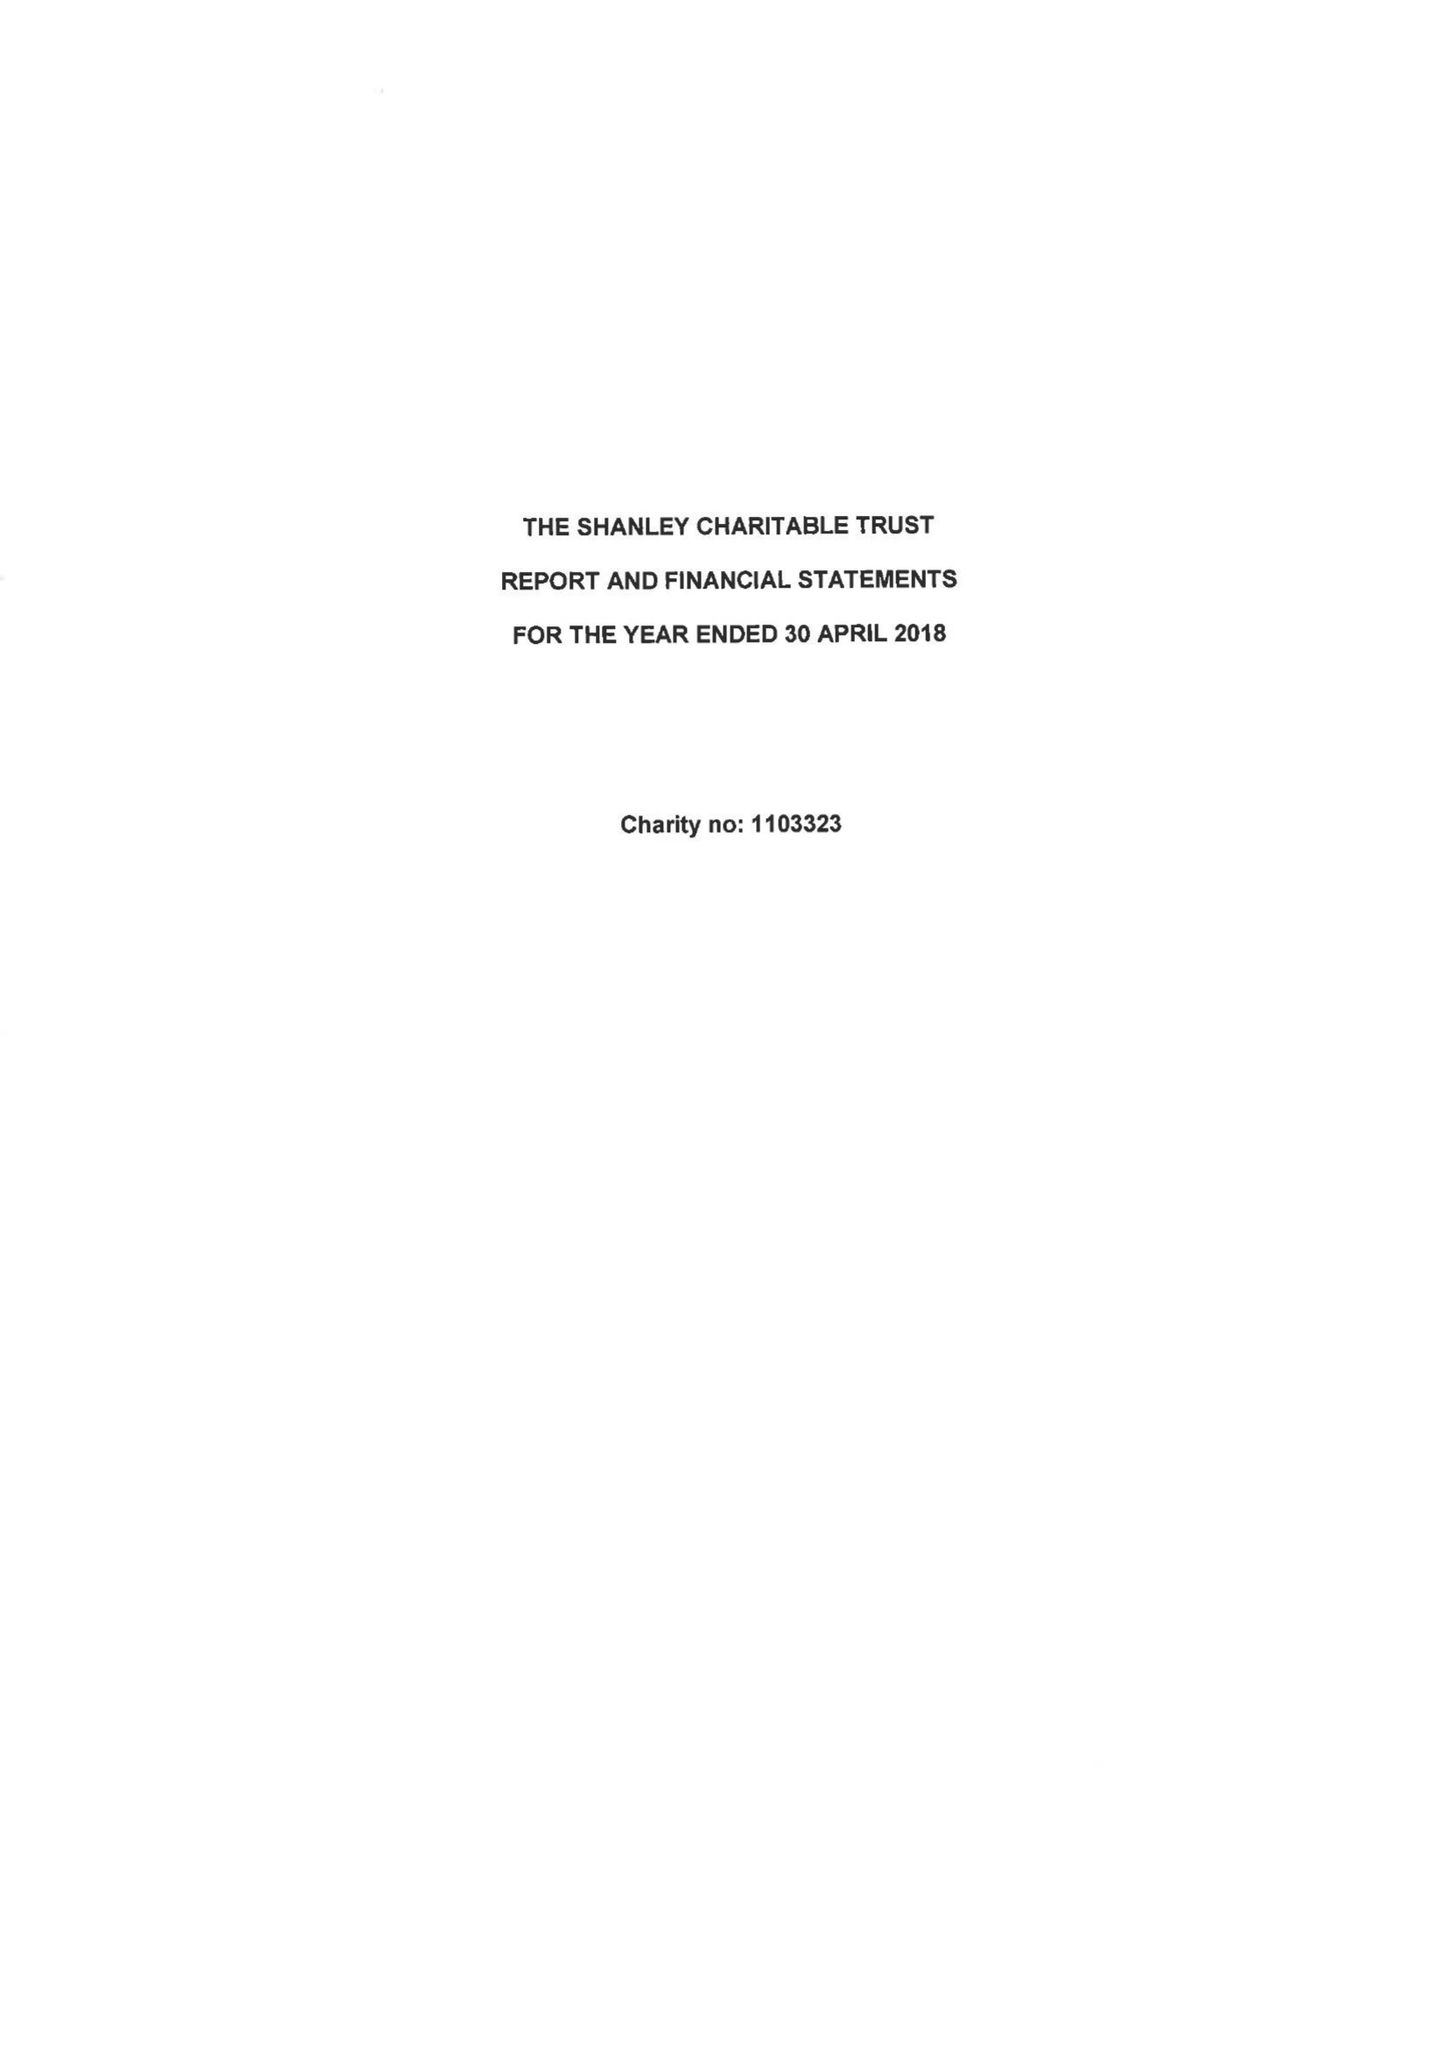What is the value for the report_date?
Answer the question using a single word or phrase. 2018-04-30 